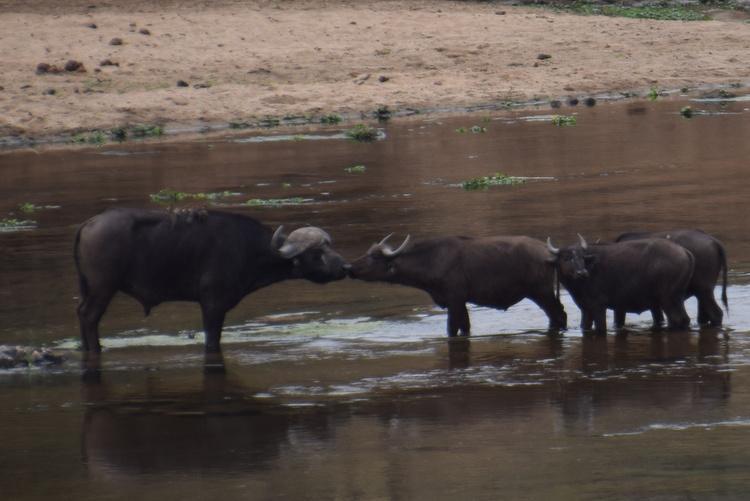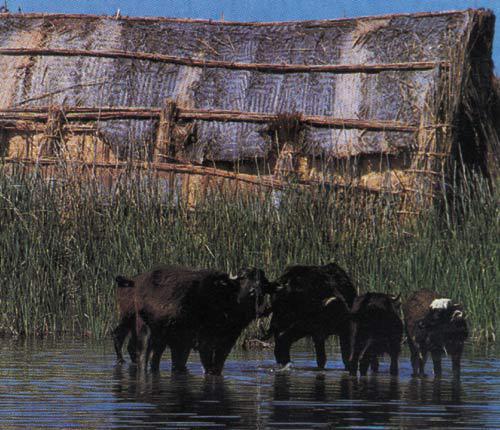The first image is the image on the left, the second image is the image on the right. Examine the images to the left and right. Is the description "there are some oxen in water." accurate? Answer yes or no. Yes. The first image is the image on the left, the second image is the image on the right. For the images shown, is this caption "There is at least one human visible." true? Answer yes or no. No. 